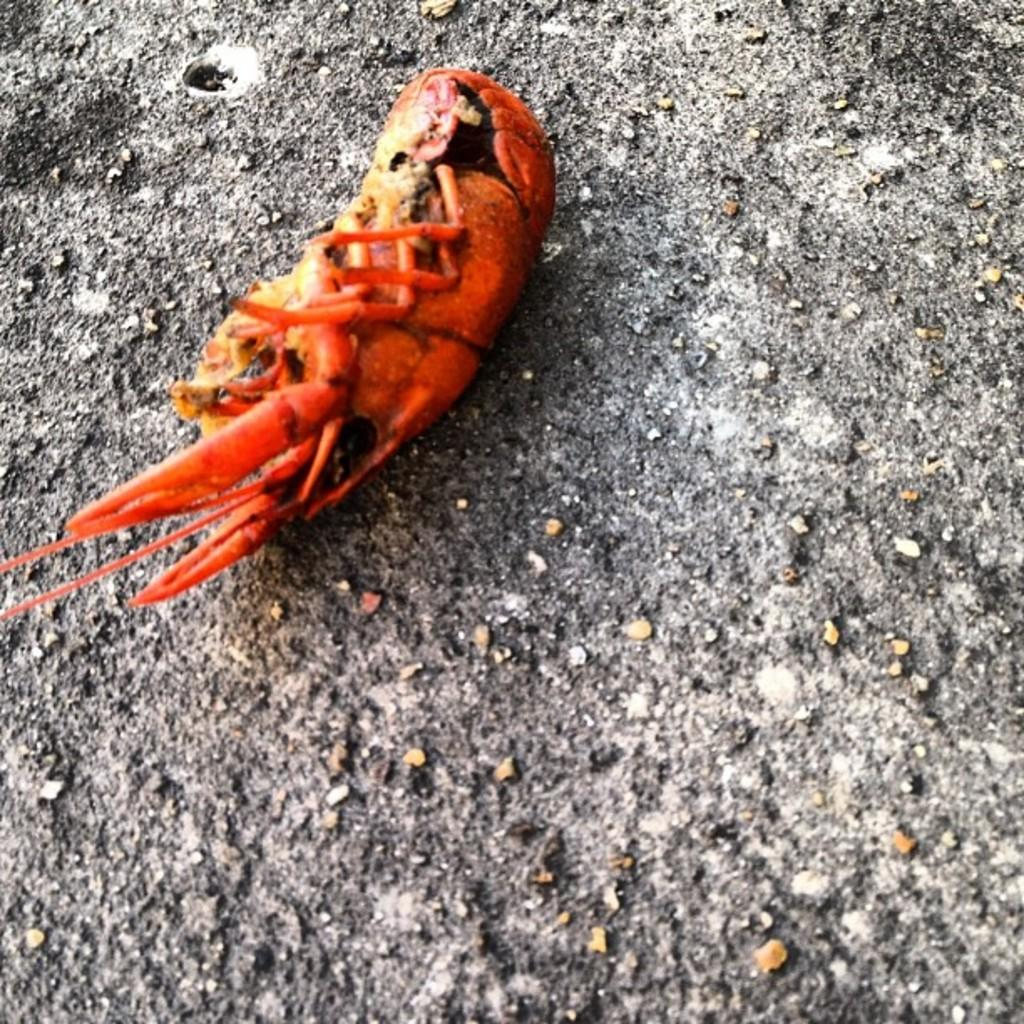What is the main subject in the center of the image? There is an insect in the center of the image. What can be seen in the background of the image? There is a wall in the background of the image. How many planes are visible in the image? There are no planes visible in the image; it features an insect and a wall in the background. What type of hope can be seen in the image? There is no representation of hope in the image; it features an insect and a wall in the background. 